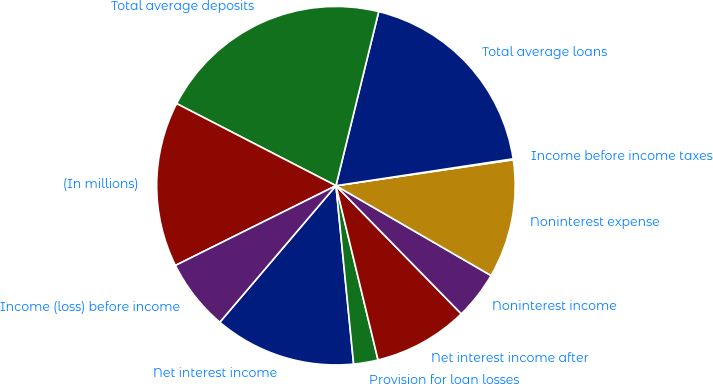Convert chart to OTSL. <chart><loc_0><loc_0><loc_500><loc_500><pie_chart><fcel>Net interest income<fcel>Provision for loan losses<fcel>Net interest income after<fcel>Noninterest income<fcel>Noninterest expense<fcel>Income before income taxes<fcel>Total average loans<fcel>Total average deposits<fcel>(In millions)<fcel>Income (loss) before income<nl><fcel>12.79%<fcel>2.2%<fcel>8.55%<fcel>4.32%<fcel>10.67%<fcel>0.08%<fcel>18.77%<fcel>21.26%<fcel>14.91%<fcel>6.44%<nl></chart> 